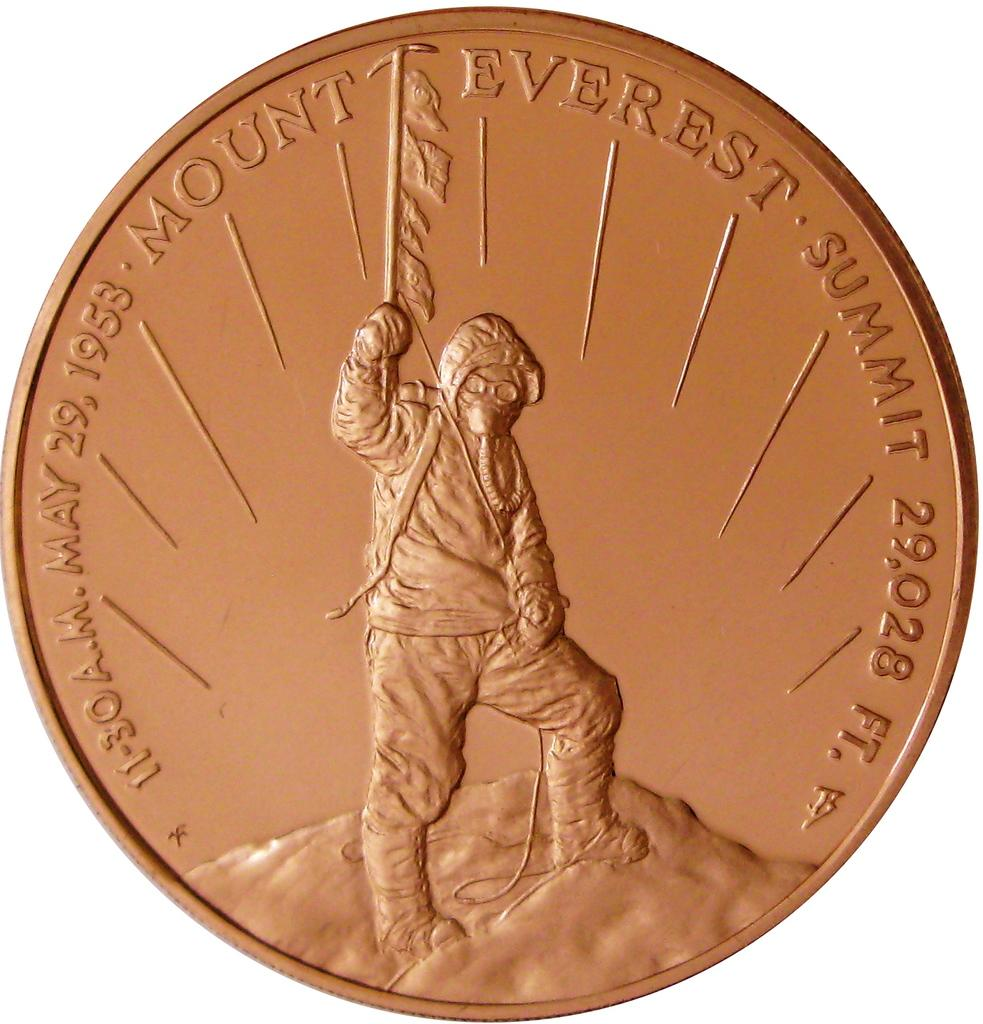<image>
Render a clear and concise summary of the photo. Copper round coin from the Mount Everest summit. 